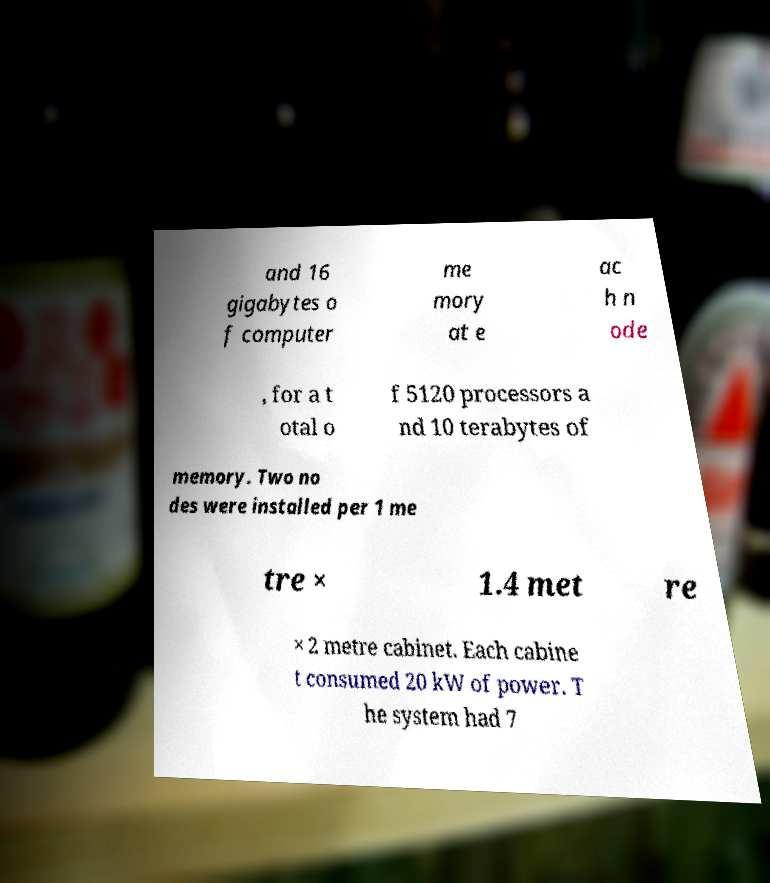For documentation purposes, I need the text within this image transcribed. Could you provide that? and 16 gigabytes o f computer me mory at e ac h n ode , for a t otal o f 5120 processors a nd 10 terabytes of memory. Two no des were installed per 1 me tre × 1.4 met re × 2 metre cabinet. Each cabine t consumed 20 kW of power. T he system had 7 